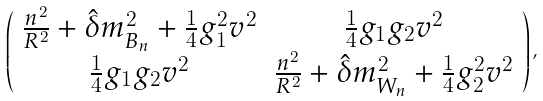<formula> <loc_0><loc_0><loc_500><loc_500>\left ( \begin{array} { c c } \frac { n ^ { 2 } } { R ^ { 2 } } + \hat { \delta } m _ { B _ { n } } ^ { 2 } + \frac { 1 } { 4 } g _ { 1 } ^ { 2 } v ^ { 2 } & \frac { 1 } { 4 } g _ { 1 } g _ { 2 } v ^ { 2 } \\ \frac { 1 } { 4 } g _ { 1 } g _ { 2 } v ^ { 2 } & \frac { n ^ { 2 } } { R ^ { 2 } } + \hat { \delta } m _ { W _ { n } } ^ { 2 } + \frac { 1 } { 4 } g _ { 2 } ^ { 2 } v ^ { 2 } \end{array} \right ) ,</formula> 